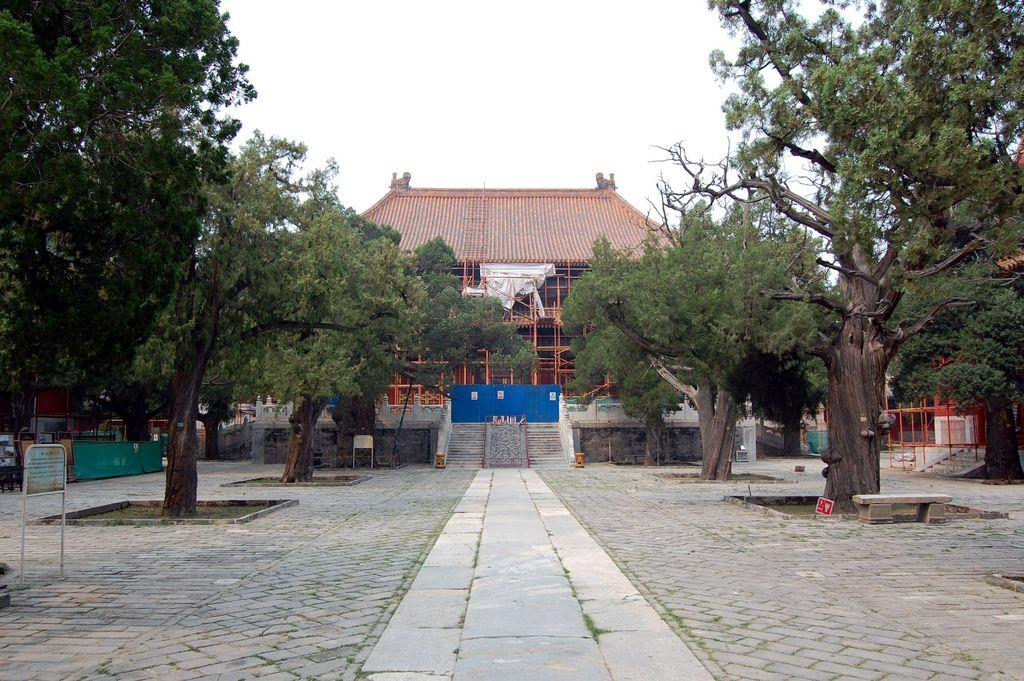What type of path is visible in the image? There is a path in the image, but the specific type of path is not mentioned. What can be used for climbing or ascending in the image? There are steps in the image that can be used for climbing or ascending. What type of vegetation is present in the image? There are trees in the image. What material is used for the boards in the image? The specific material of the boards is not mentioned in the facts. What type of structure is visible in the image? There is a building in the image. What can be used for sitting in the image? There is a bench in the image that can be used for sitting. What type of barrier is present in the image? There are walls in the image that can serve as barriers. What objects are present in the image? There are some objects in the image, but their specific nature is not mentioned. What is visible in the background of the image? The sky is visible in the background of the image. What type of apple pie can be seen on the bench in the image? There is no apple pie present in the image; it only features a bench. What is the value of the building in the image? The value of the building is not mentioned in the image, as it does not provide any information about its worth or significance. 